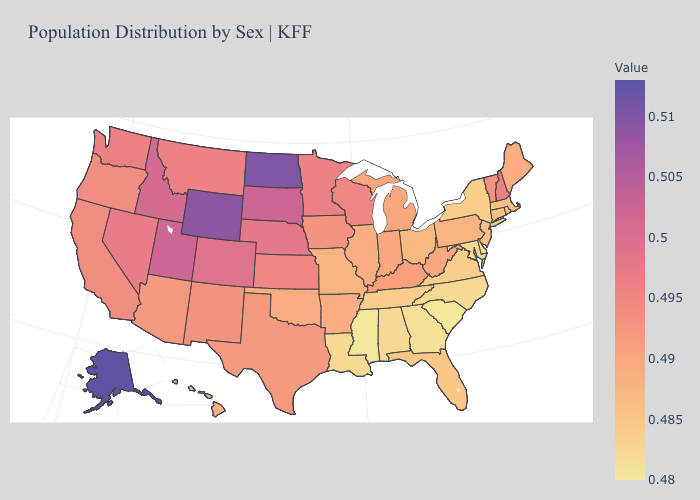Does Arkansas have a lower value than Rhode Island?
Short answer required. No. Among the states that border Kansas , does Colorado have the highest value?
Give a very brief answer. Yes. Among the states that border Louisiana , does Arkansas have the lowest value?
Be succinct. No. Which states hav the highest value in the Northeast?
Write a very short answer. New Hampshire. 